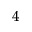Convert formula to latex. <formula><loc_0><loc_0><loc_500><loc_500>_ { 4 }</formula> 